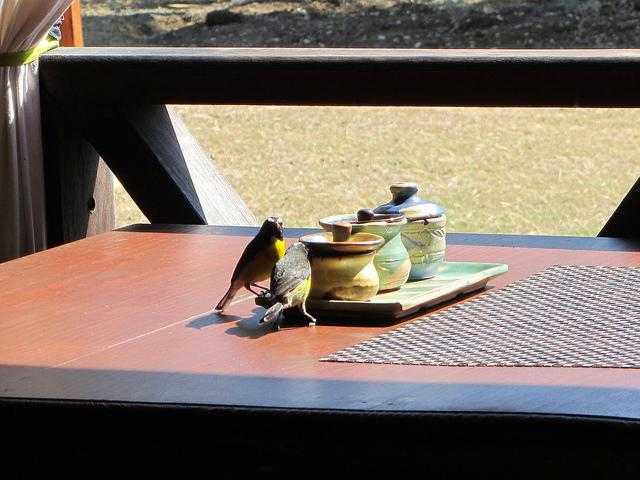Where is this table located at? outside 